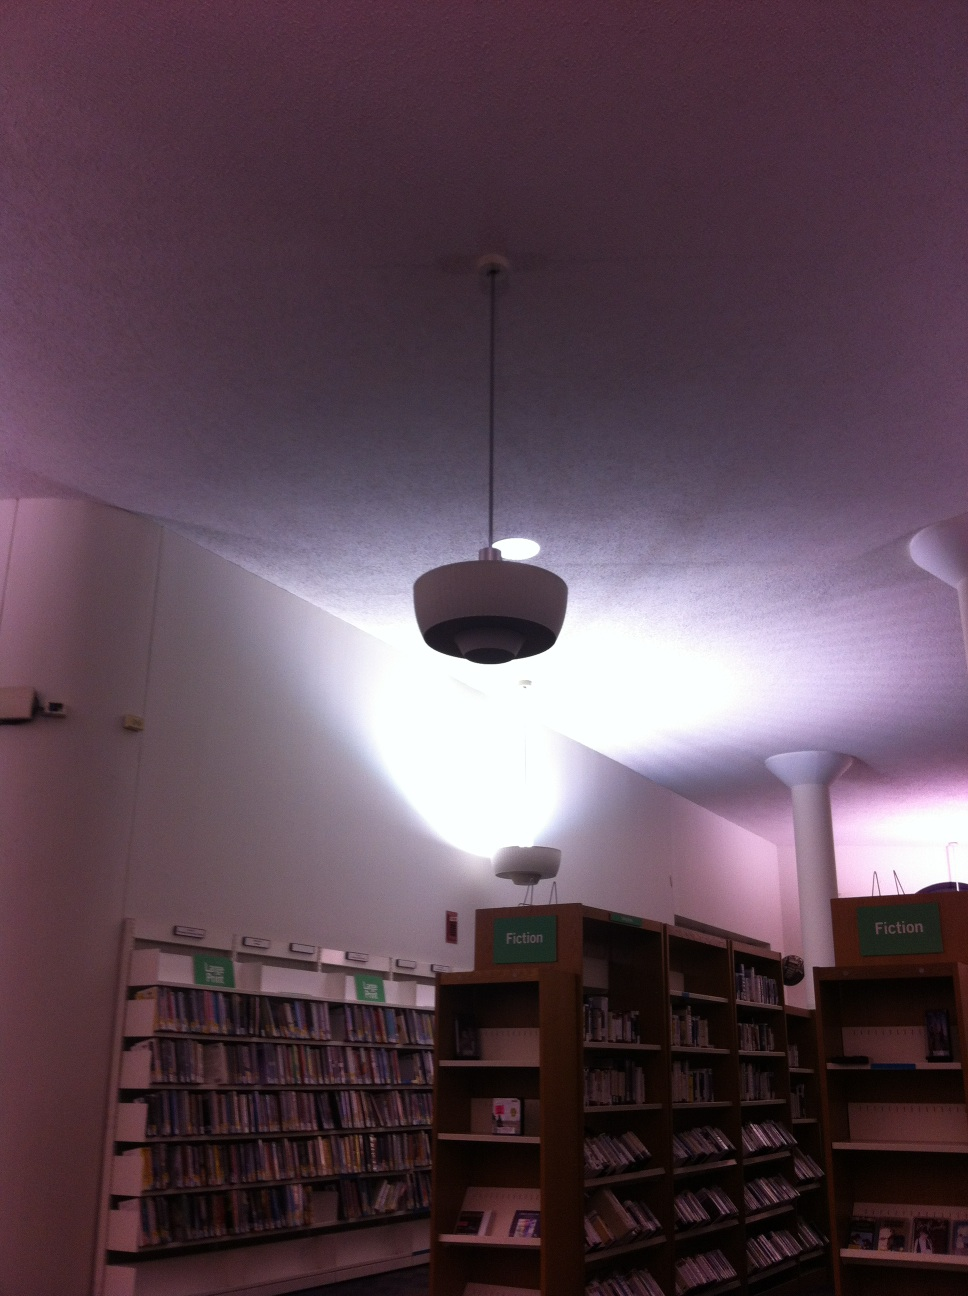What's the history behind this library? This library has a rich history dating back several decades. Established to serve the local community, it has grown from a modest collection of books to a comprehensive resource center. Over the years, it has been renovated to include modern amenities and technology, ensuring that it remains relevant and useful to all age groups. 